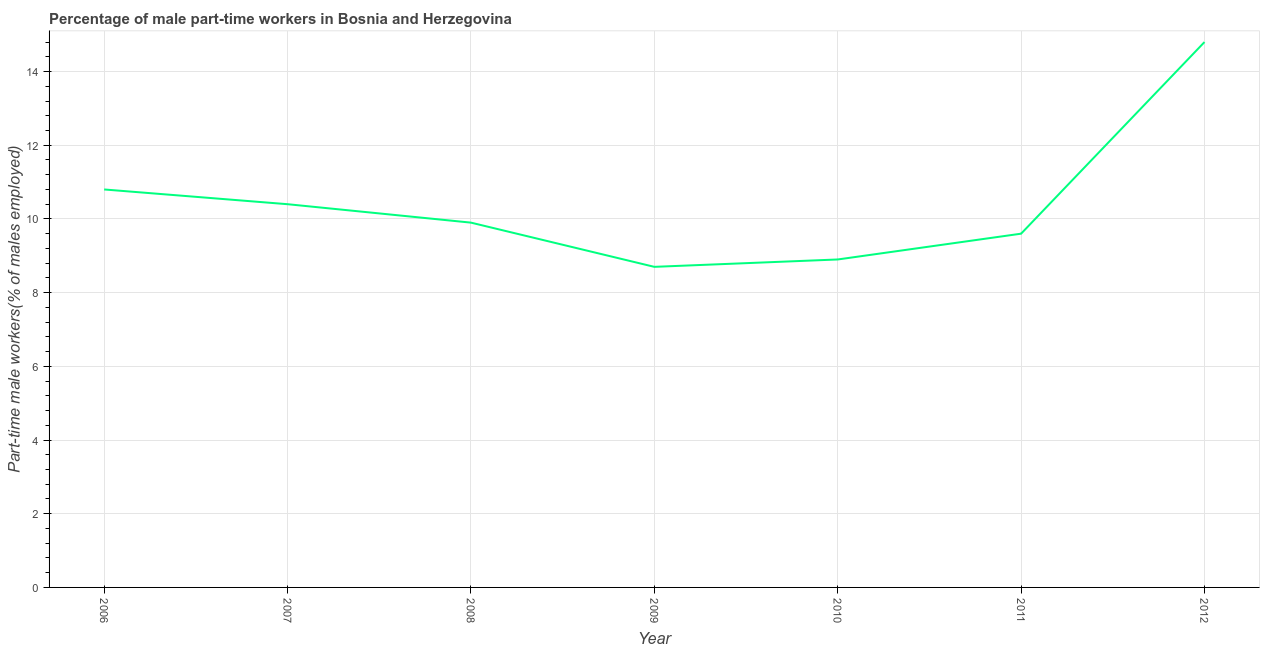What is the percentage of part-time male workers in 2007?
Make the answer very short. 10.4. Across all years, what is the maximum percentage of part-time male workers?
Offer a terse response. 14.8. Across all years, what is the minimum percentage of part-time male workers?
Keep it short and to the point. 8.7. What is the sum of the percentage of part-time male workers?
Your answer should be compact. 73.1. What is the difference between the percentage of part-time male workers in 2007 and 2011?
Ensure brevity in your answer.  0.8. What is the average percentage of part-time male workers per year?
Offer a very short reply. 10.44. What is the median percentage of part-time male workers?
Give a very brief answer. 9.9. In how many years, is the percentage of part-time male workers greater than 5.2 %?
Your answer should be very brief. 7. Do a majority of the years between 2009 and 2006 (inclusive) have percentage of part-time male workers greater than 5.2 %?
Keep it short and to the point. Yes. What is the ratio of the percentage of part-time male workers in 2008 to that in 2010?
Provide a succinct answer. 1.11. Is the difference between the percentage of part-time male workers in 2006 and 2011 greater than the difference between any two years?
Provide a succinct answer. No. Is the sum of the percentage of part-time male workers in 2007 and 2010 greater than the maximum percentage of part-time male workers across all years?
Your response must be concise. Yes. What is the difference between the highest and the lowest percentage of part-time male workers?
Make the answer very short. 6.1. Does the graph contain any zero values?
Offer a terse response. No. What is the title of the graph?
Keep it short and to the point. Percentage of male part-time workers in Bosnia and Herzegovina. What is the label or title of the Y-axis?
Offer a very short reply. Part-time male workers(% of males employed). What is the Part-time male workers(% of males employed) of 2006?
Provide a succinct answer. 10.8. What is the Part-time male workers(% of males employed) of 2007?
Provide a succinct answer. 10.4. What is the Part-time male workers(% of males employed) of 2008?
Your answer should be very brief. 9.9. What is the Part-time male workers(% of males employed) in 2009?
Your answer should be compact. 8.7. What is the Part-time male workers(% of males employed) of 2010?
Give a very brief answer. 8.9. What is the Part-time male workers(% of males employed) of 2011?
Give a very brief answer. 9.6. What is the Part-time male workers(% of males employed) in 2012?
Provide a succinct answer. 14.8. What is the difference between the Part-time male workers(% of males employed) in 2006 and 2007?
Give a very brief answer. 0.4. What is the difference between the Part-time male workers(% of males employed) in 2006 and 2008?
Keep it short and to the point. 0.9. What is the difference between the Part-time male workers(% of males employed) in 2006 and 2009?
Keep it short and to the point. 2.1. What is the difference between the Part-time male workers(% of males employed) in 2006 and 2010?
Your answer should be compact. 1.9. What is the difference between the Part-time male workers(% of males employed) in 2007 and 2010?
Offer a very short reply. 1.5. What is the difference between the Part-time male workers(% of males employed) in 2008 and 2009?
Give a very brief answer. 1.2. What is the difference between the Part-time male workers(% of males employed) in 2008 and 2010?
Your answer should be compact. 1. What is the difference between the Part-time male workers(% of males employed) in 2008 and 2011?
Give a very brief answer. 0.3. What is the difference between the Part-time male workers(% of males employed) in 2009 and 2010?
Give a very brief answer. -0.2. What is the difference between the Part-time male workers(% of males employed) in 2009 and 2012?
Your answer should be very brief. -6.1. What is the difference between the Part-time male workers(% of males employed) in 2010 and 2011?
Give a very brief answer. -0.7. What is the ratio of the Part-time male workers(% of males employed) in 2006 to that in 2007?
Keep it short and to the point. 1.04. What is the ratio of the Part-time male workers(% of males employed) in 2006 to that in 2008?
Your answer should be very brief. 1.09. What is the ratio of the Part-time male workers(% of males employed) in 2006 to that in 2009?
Provide a short and direct response. 1.24. What is the ratio of the Part-time male workers(% of males employed) in 2006 to that in 2010?
Provide a succinct answer. 1.21. What is the ratio of the Part-time male workers(% of males employed) in 2006 to that in 2012?
Your answer should be compact. 0.73. What is the ratio of the Part-time male workers(% of males employed) in 2007 to that in 2008?
Ensure brevity in your answer.  1.05. What is the ratio of the Part-time male workers(% of males employed) in 2007 to that in 2009?
Make the answer very short. 1.2. What is the ratio of the Part-time male workers(% of males employed) in 2007 to that in 2010?
Provide a succinct answer. 1.17. What is the ratio of the Part-time male workers(% of males employed) in 2007 to that in 2011?
Offer a very short reply. 1.08. What is the ratio of the Part-time male workers(% of males employed) in 2007 to that in 2012?
Give a very brief answer. 0.7. What is the ratio of the Part-time male workers(% of males employed) in 2008 to that in 2009?
Offer a very short reply. 1.14. What is the ratio of the Part-time male workers(% of males employed) in 2008 to that in 2010?
Your answer should be very brief. 1.11. What is the ratio of the Part-time male workers(% of males employed) in 2008 to that in 2011?
Offer a terse response. 1.03. What is the ratio of the Part-time male workers(% of males employed) in 2008 to that in 2012?
Your answer should be very brief. 0.67. What is the ratio of the Part-time male workers(% of males employed) in 2009 to that in 2011?
Offer a very short reply. 0.91. What is the ratio of the Part-time male workers(% of males employed) in 2009 to that in 2012?
Provide a short and direct response. 0.59. What is the ratio of the Part-time male workers(% of males employed) in 2010 to that in 2011?
Your answer should be compact. 0.93. What is the ratio of the Part-time male workers(% of males employed) in 2010 to that in 2012?
Your answer should be compact. 0.6. What is the ratio of the Part-time male workers(% of males employed) in 2011 to that in 2012?
Your answer should be very brief. 0.65. 